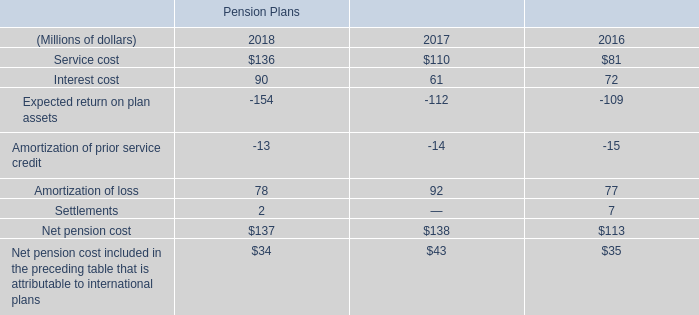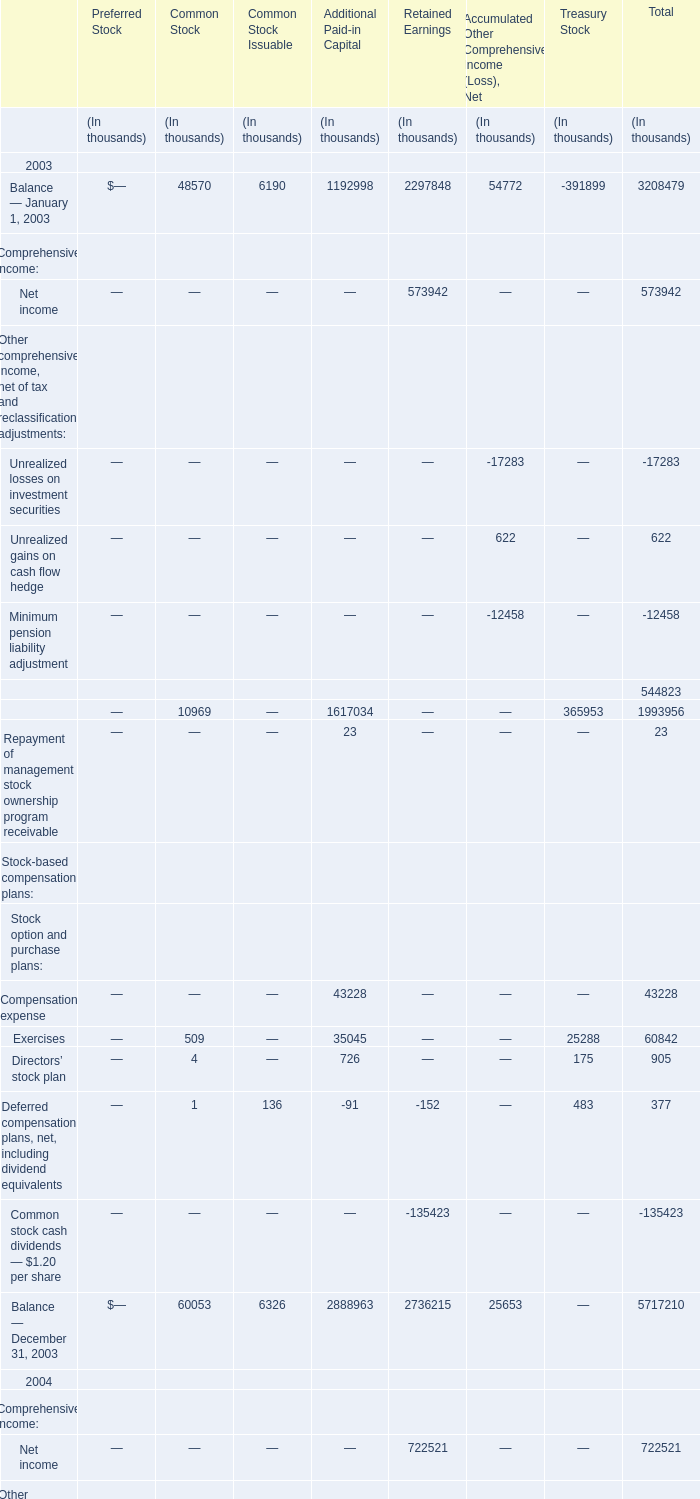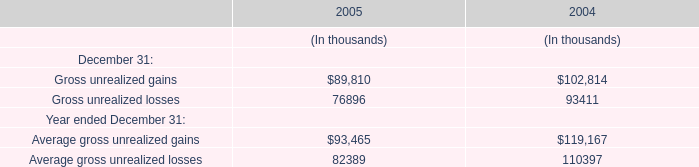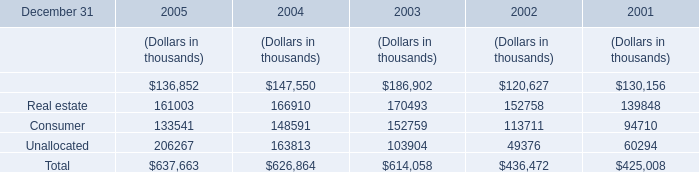What is the value of the Exercises for Common Stock in the year with the least Net income for Retained Earnings? (in thousand) 
Answer: 509. 